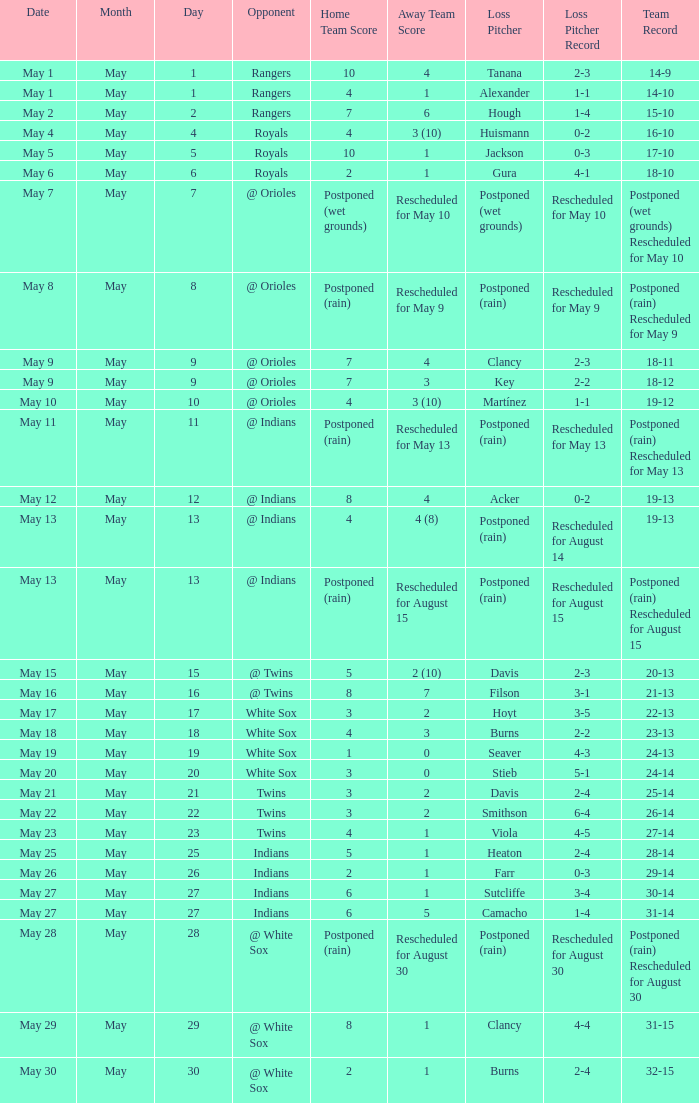Who was the opponent at the game when the record was 22-13? White Sox. 